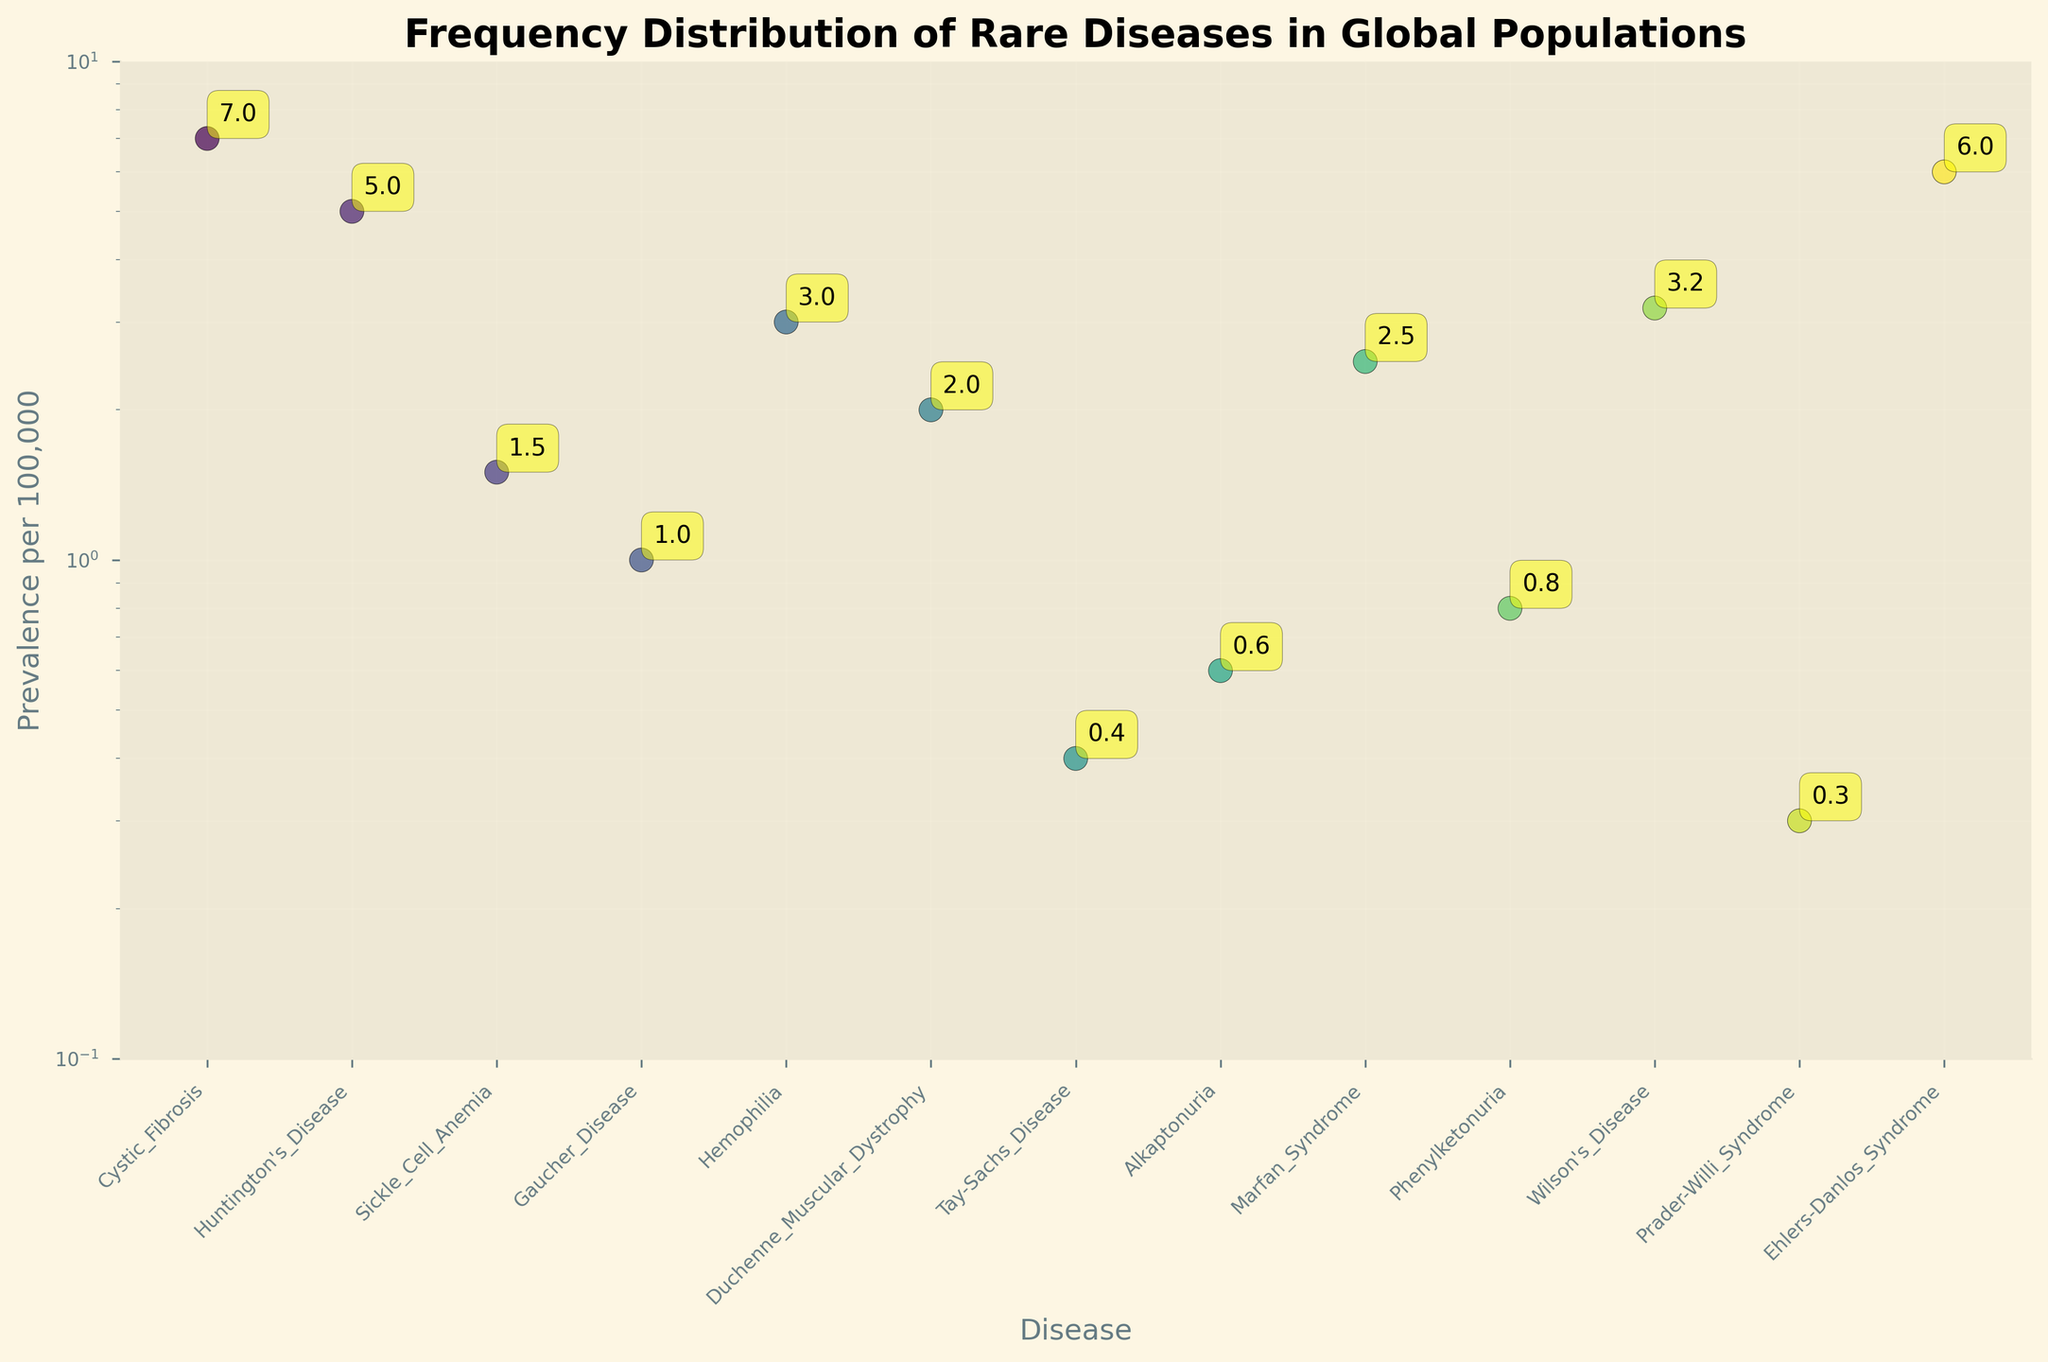Which disease has the highest prevalence per 100,000? By looking at the scatter plot, we can see that Cystic_Fibrosis has the highest label for prevalence per 100,000 amongst all the diseases displayed.
Answer: Cystic_Fibrosis How does the prevalence of Sickle Cell Anemia compare to Hemophilia? From the scatter plot, Sickle Cell Anemia has a prevalence of 1.5 per 100,000, while Hemophilia has a prevalence of 3.0 per 100,000. By comparison, Hemophilia has a higher prevalence.
Answer: Hemophilia has a higher prevalence What is the approximate ratio of the prevalence of Marfan Syndrome to Tay-Sachs Disease? Marfan Syndrome has a prevalence of 2.5 per 100,000, and Tay-Sachs Disease has a prevalence of 0.4 per 100,000. The ratio is calculated as 2.5 / 0.4, resulting in approximately 6.25.
Answer: 6.25 Which diseases have a prevalence of less than 1 per 100,000? The diseases with prevalence less than 1 per 100,000 in the scatter plot are Tay-Sachs Disease, Alkaptonuria, Phenylketonuria, and Prader-Willi Syndrome.
Answer: Tay-Sachs Disease, Alkaptonuria, Phenylketonuria, Prader-Willi Syndrome What is the median prevalence value of the diseases listed? To find the median, we first list the prevalence values in ascending order: 0.3, 0.4, 0.6, 0.8, 1.0, 1.5, 2.0, 2.5, 3.0, 3.2, 5.0, 6.0, 7.0. The median value is the middle value, which is 2.0.
Answer: 2.0 How does the prevalence of Wilson's Disease compare to Huntingtons Disease? Wilson's Disease has a prevalence of 3.2 per 100,000, while Huntington's Disease has a prevalence of 5.0 per 100,000. By comparison, Huntington's Disease has a higher prevalence.
Answer: Huntington's Disease has a higher prevalence What is the range of prevalence values in the dataset? The range is found by subtracting the smallest value from the largest. The smallest prevalence value is 0.3 (Prader-Willi Syndrome), and the largest is 7.0 (Cystic Fibrosis), so the range is 7.0 - 0.3 = 6.7.
Answer: 6.7 Which diseases fall within the prevalence range of 0.5 to 3 per 100,000? Reviewing the scatter plot, the diseases with prevalence within the range 0.5 to 3 per 100,000 are Alkaptonuria, Phenylketonuria, Sickle Cell Anemia, Hemophilia, Duchenne Muscular Dystrophy, and Marfan Syndrome.
Answer: Alkaptonuria, Phenylketonuria, Sickle Cell Anemia, Hemophilia, Duchenne Muscular Dystrophy, Marfan Syndrome What is the log-scaled value of the prevalence for Ehlers-Danlos Syndrome at approximately 1 per 100,000? On a logarithmic scale, 1 per 100,000 is plotted at the position corresponding to log(1), which is 0 on the log scale. This means Ehlers-Danlos Syndrome, at approximately 6 per 100,000, will be higher up compared to this baseline.
Answer: 1 